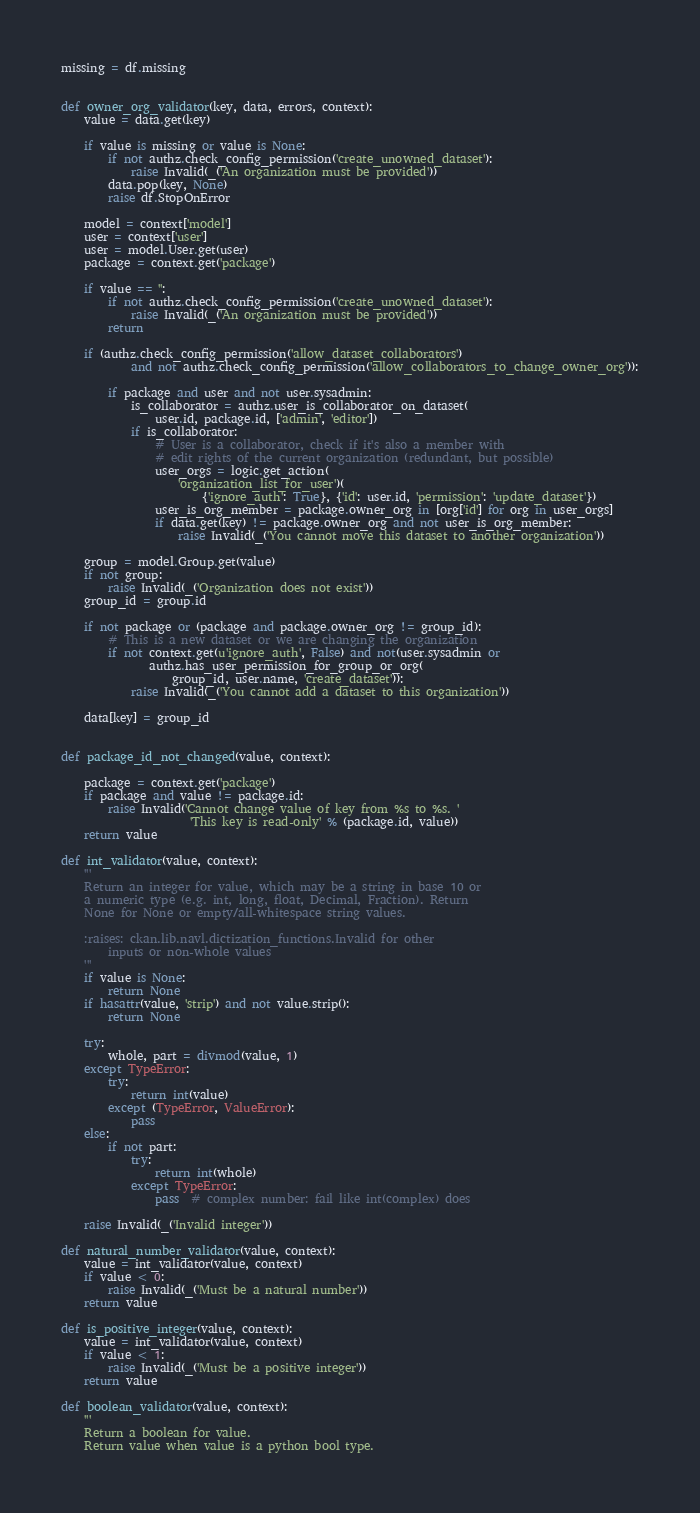<code> <loc_0><loc_0><loc_500><loc_500><_Python_>missing = df.missing


def owner_org_validator(key, data, errors, context):
    value = data.get(key)

    if value is missing or value is None:
        if not authz.check_config_permission('create_unowned_dataset'):
            raise Invalid(_('An organization must be provided'))
        data.pop(key, None)
        raise df.StopOnError

    model = context['model']
    user = context['user']
    user = model.User.get(user)
    package = context.get('package')

    if value == '':
        if not authz.check_config_permission('create_unowned_dataset'):
            raise Invalid(_('An organization must be provided'))
        return

    if (authz.check_config_permission('allow_dataset_collaborators')
            and not authz.check_config_permission('allow_collaborators_to_change_owner_org')):

        if package and user and not user.sysadmin:
            is_collaborator = authz.user_is_collaborator_on_dataset(
                user.id, package.id, ['admin', 'editor'])
            if is_collaborator:
                # User is a collaborator, check if it's also a member with
                # edit rights of the current organization (redundant, but possible)
                user_orgs = logic.get_action(
                    'organization_list_for_user')(
                        {'ignore_auth': True}, {'id': user.id, 'permission': 'update_dataset'})
                user_is_org_member = package.owner_org in [org['id'] for org in user_orgs]
                if data.get(key) != package.owner_org and not user_is_org_member:
                    raise Invalid(_('You cannot move this dataset to another organization'))

    group = model.Group.get(value)
    if not group:
        raise Invalid(_('Organization does not exist'))
    group_id = group.id

    if not package or (package and package.owner_org != group_id):
        # This is a new dataset or we are changing the organization
        if not context.get(u'ignore_auth', False) and not(user.sysadmin or
               authz.has_user_permission_for_group_or_org(
                   group_id, user.name, 'create_dataset')):
            raise Invalid(_('You cannot add a dataset to this organization'))

    data[key] = group_id


def package_id_not_changed(value, context):

    package = context.get('package')
    if package and value != package.id:
        raise Invalid('Cannot change value of key from %s to %s. '
                      'This key is read-only' % (package.id, value))
    return value

def int_validator(value, context):
    '''
    Return an integer for value, which may be a string in base 10 or
    a numeric type (e.g. int, long, float, Decimal, Fraction). Return
    None for None or empty/all-whitespace string values.

    :raises: ckan.lib.navl.dictization_functions.Invalid for other
        inputs or non-whole values
    '''
    if value is None:
        return None
    if hasattr(value, 'strip') and not value.strip():
        return None

    try:
        whole, part = divmod(value, 1)
    except TypeError:
        try:
            return int(value)
        except (TypeError, ValueError):
            pass
    else:
        if not part:
            try:
                return int(whole)
            except TypeError:
                pass  # complex number: fail like int(complex) does

    raise Invalid(_('Invalid integer'))

def natural_number_validator(value, context):
    value = int_validator(value, context)
    if value < 0:
        raise Invalid(_('Must be a natural number'))
    return value

def is_positive_integer(value, context):
    value = int_validator(value, context)
    if value < 1:
        raise Invalid(_('Must be a positive integer'))
    return value

def boolean_validator(value, context):
    '''
    Return a boolean for value.
    Return value when value is a python bool type.</code> 